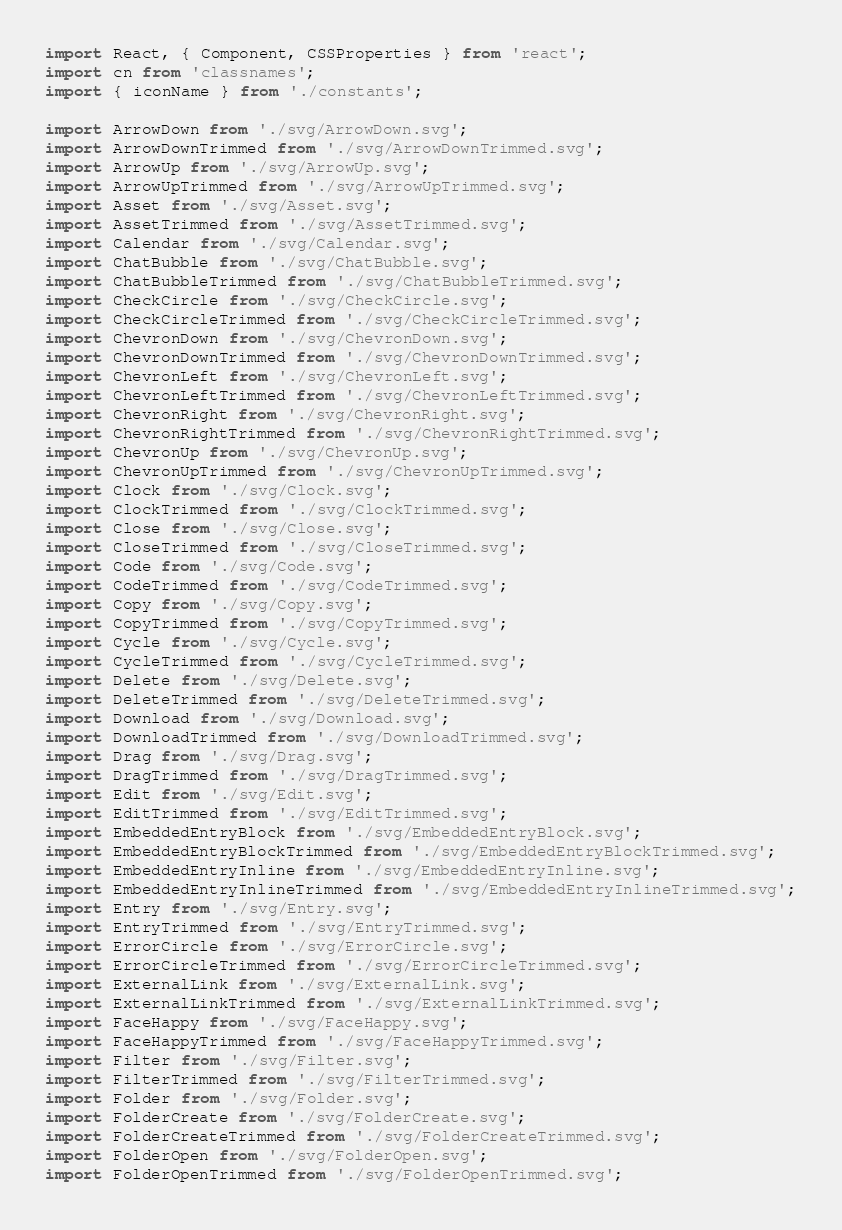Convert code to text. <code><loc_0><loc_0><loc_500><loc_500><_TypeScript_>import React, { Component, CSSProperties } from 'react';
import cn from 'classnames';
import { iconName } from './constants';

import ArrowDown from './svg/ArrowDown.svg';
import ArrowDownTrimmed from './svg/ArrowDownTrimmed.svg';
import ArrowUp from './svg/ArrowUp.svg';
import ArrowUpTrimmed from './svg/ArrowUpTrimmed.svg';
import Asset from './svg/Asset.svg';
import AssetTrimmed from './svg/AssetTrimmed.svg';
import Calendar from './svg/Calendar.svg';
import ChatBubble from './svg/ChatBubble.svg';
import ChatBubbleTrimmed from './svg/ChatBubbleTrimmed.svg';
import CheckCircle from './svg/CheckCircle.svg';
import CheckCircleTrimmed from './svg/CheckCircleTrimmed.svg';
import ChevronDown from './svg/ChevronDown.svg';
import ChevronDownTrimmed from './svg/ChevronDownTrimmed.svg';
import ChevronLeft from './svg/ChevronLeft.svg';
import ChevronLeftTrimmed from './svg/ChevronLeftTrimmed.svg';
import ChevronRight from './svg/ChevronRight.svg';
import ChevronRightTrimmed from './svg/ChevronRightTrimmed.svg';
import ChevronUp from './svg/ChevronUp.svg';
import ChevronUpTrimmed from './svg/ChevronUpTrimmed.svg';
import Clock from './svg/Clock.svg';
import ClockTrimmed from './svg/ClockTrimmed.svg';
import Close from './svg/Close.svg';
import CloseTrimmed from './svg/CloseTrimmed.svg';
import Code from './svg/Code.svg';
import CodeTrimmed from './svg/CodeTrimmed.svg';
import Copy from './svg/Copy.svg';
import CopyTrimmed from './svg/CopyTrimmed.svg';
import Cycle from './svg/Cycle.svg';
import CycleTrimmed from './svg/CycleTrimmed.svg';
import Delete from './svg/Delete.svg';
import DeleteTrimmed from './svg/DeleteTrimmed.svg';
import Download from './svg/Download.svg';
import DownloadTrimmed from './svg/DownloadTrimmed.svg';
import Drag from './svg/Drag.svg';
import DragTrimmed from './svg/DragTrimmed.svg';
import Edit from './svg/Edit.svg';
import EditTrimmed from './svg/EditTrimmed.svg';
import EmbeddedEntryBlock from './svg/EmbeddedEntryBlock.svg';
import EmbeddedEntryBlockTrimmed from './svg/EmbeddedEntryBlockTrimmed.svg';
import EmbeddedEntryInline from './svg/EmbeddedEntryInline.svg';
import EmbeddedEntryInlineTrimmed from './svg/EmbeddedEntryInlineTrimmed.svg';
import Entry from './svg/Entry.svg';
import EntryTrimmed from './svg/EntryTrimmed.svg';
import ErrorCircle from './svg/ErrorCircle.svg';
import ErrorCircleTrimmed from './svg/ErrorCircleTrimmed.svg';
import ExternalLink from './svg/ExternalLink.svg';
import ExternalLinkTrimmed from './svg/ExternalLinkTrimmed.svg';
import FaceHappy from './svg/FaceHappy.svg';
import FaceHappyTrimmed from './svg/FaceHappyTrimmed.svg';
import Filter from './svg/Filter.svg';
import FilterTrimmed from './svg/FilterTrimmed.svg';
import Folder from './svg/Folder.svg';
import FolderCreate from './svg/FolderCreate.svg';
import FolderCreateTrimmed from './svg/FolderCreateTrimmed.svg';
import FolderOpen from './svg/FolderOpen.svg';
import FolderOpenTrimmed from './svg/FolderOpenTrimmed.svg';</code> 